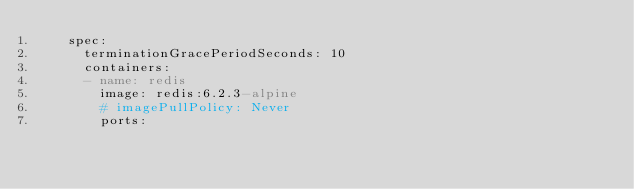Convert code to text. <code><loc_0><loc_0><loc_500><loc_500><_YAML_>    spec:
      terminationGracePeriodSeconds: 10
      containers:
      - name: redis
        image: redis:6.2.3-alpine
        # imagePullPolicy: Never
        ports:</code> 